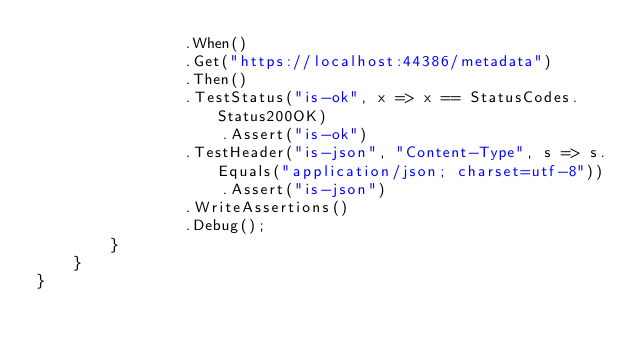<code> <loc_0><loc_0><loc_500><loc_500><_C#_>                .When()
                .Get("https://localhost:44386/metadata")
                .Then()
                .TestStatus("is-ok", x => x == StatusCodes.Status200OK)
                    .Assert("is-ok")
                .TestHeader("is-json", "Content-Type", s => s.Equals("application/json; charset=utf-8"))
                    .Assert("is-json")
                .WriteAssertions()
                .Debug();
        }
    }
}
</code> 